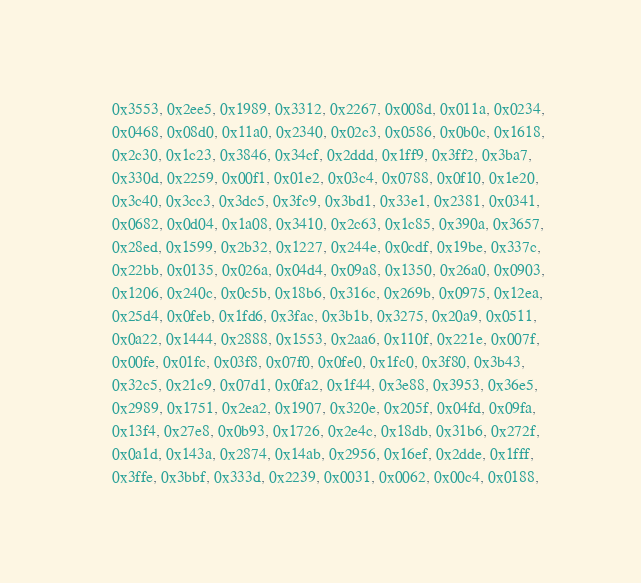<code> <loc_0><loc_0><loc_500><loc_500><_C_>    0x3553, 0x2ee5, 0x1989, 0x3312, 0x2267, 0x008d, 0x011a, 0x0234,
    0x0468, 0x08d0, 0x11a0, 0x2340, 0x02c3, 0x0586, 0x0b0c, 0x1618,
    0x2c30, 0x1c23, 0x3846, 0x34cf, 0x2ddd, 0x1ff9, 0x3ff2, 0x3ba7,
    0x330d, 0x2259, 0x00f1, 0x01e2, 0x03c4, 0x0788, 0x0f10, 0x1e20,
    0x3c40, 0x3cc3, 0x3dc5, 0x3fc9, 0x3bd1, 0x33e1, 0x2381, 0x0341,
    0x0682, 0x0d04, 0x1a08, 0x3410, 0x2c63, 0x1c85, 0x390a, 0x3657,
    0x28ed, 0x1599, 0x2b32, 0x1227, 0x244e, 0x0cdf, 0x19be, 0x337c,
    0x22bb, 0x0135, 0x026a, 0x04d4, 0x09a8, 0x1350, 0x26a0, 0x0903,
    0x1206, 0x240c, 0x0c5b, 0x18b6, 0x316c, 0x269b, 0x0975, 0x12ea,
    0x25d4, 0x0feb, 0x1fd6, 0x3fac, 0x3b1b, 0x3275, 0x20a9, 0x0511,
    0x0a22, 0x1444, 0x2888, 0x1553, 0x2aa6, 0x110f, 0x221e, 0x007f,
    0x00fe, 0x01fc, 0x03f8, 0x07f0, 0x0fe0, 0x1fc0, 0x3f80, 0x3b43,
    0x32c5, 0x21c9, 0x07d1, 0x0fa2, 0x1f44, 0x3e88, 0x3953, 0x36e5,
    0x2989, 0x1751, 0x2ea2, 0x1907, 0x320e, 0x205f, 0x04fd, 0x09fa,
    0x13f4, 0x27e8, 0x0b93, 0x1726, 0x2e4c, 0x18db, 0x31b6, 0x272f,
    0x0a1d, 0x143a, 0x2874, 0x14ab, 0x2956, 0x16ef, 0x2dde, 0x1fff,
    0x3ffe, 0x3bbf, 0x333d, 0x2239, 0x0031, 0x0062, 0x00c4, 0x0188,</code> 